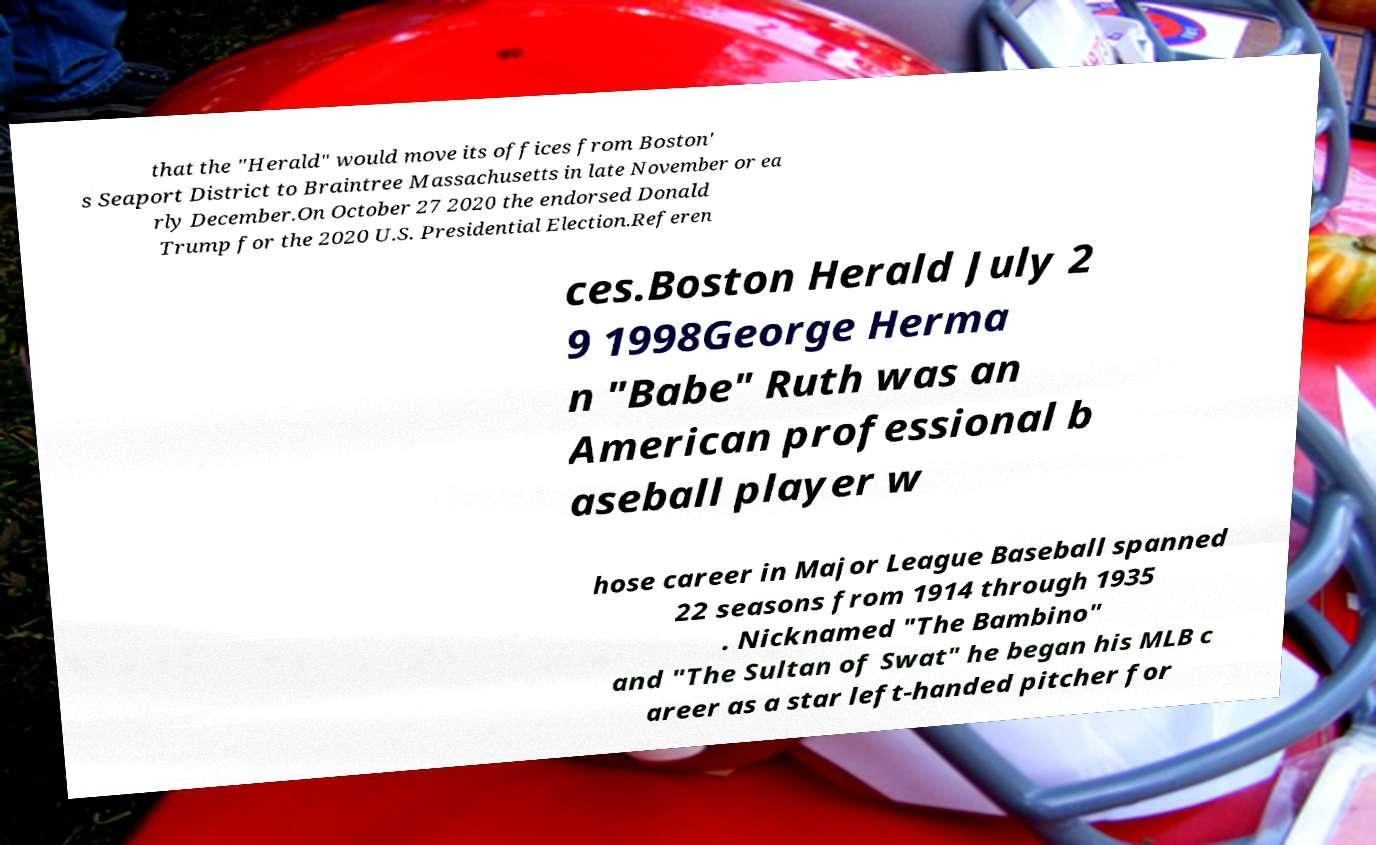Could you assist in decoding the text presented in this image and type it out clearly? that the "Herald" would move its offices from Boston' s Seaport District to Braintree Massachusetts in late November or ea rly December.On October 27 2020 the endorsed Donald Trump for the 2020 U.S. Presidential Election.Referen ces.Boston Herald July 2 9 1998George Herma n "Babe" Ruth was an American professional b aseball player w hose career in Major League Baseball spanned 22 seasons from 1914 through 1935 . Nicknamed "The Bambino" and "The Sultan of Swat" he began his MLB c areer as a star left-handed pitcher for 